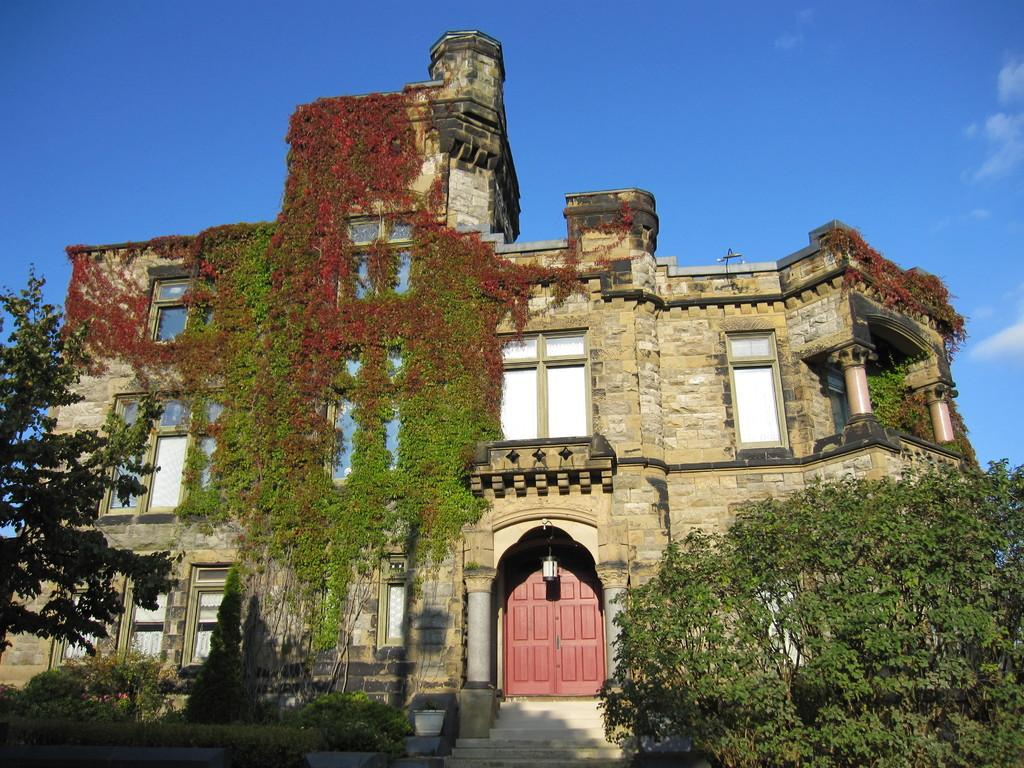What type of structure is visible in the image? There is a building in the image. What features can be seen on the building? The building has windows and a door. What is located in front of the building? There are trees, plants, and steps in front of the building. What can be seen behind the building? The sky is visible behind the building. Can you tell me how many volleyballs are on the roof of the building? There are no volleyballs visible on the roof of the building in the image. What type of ticket is required to enter the building? There is no mention of a ticket or any requirement to enter the building in the image. 